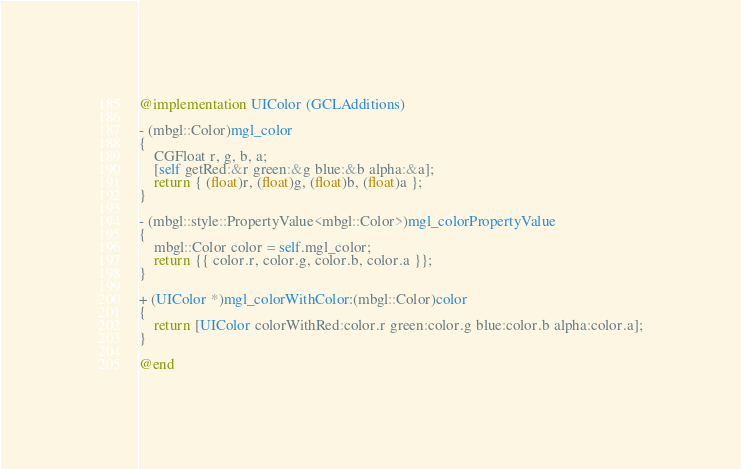Convert code to text. <code><loc_0><loc_0><loc_500><loc_500><_ObjectiveC_>
@implementation UIColor (GCLAdditions)

- (mbgl::Color)mgl_color
{
    CGFloat r, g, b, a;
    [self getRed:&r green:&g blue:&b alpha:&a];
    return { (float)r, (float)g, (float)b, (float)a };
}

- (mbgl::style::PropertyValue<mbgl::Color>)mgl_colorPropertyValue
{
    mbgl::Color color = self.mgl_color;
    return {{ color.r, color.g, color.b, color.a }};
}

+ (UIColor *)mgl_colorWithColor:(mbgl::Color)color
{
    return [UIColor colorWithRed:color.r green:color.g blue:color.b alpha:color.a];
}

@end
</code> 